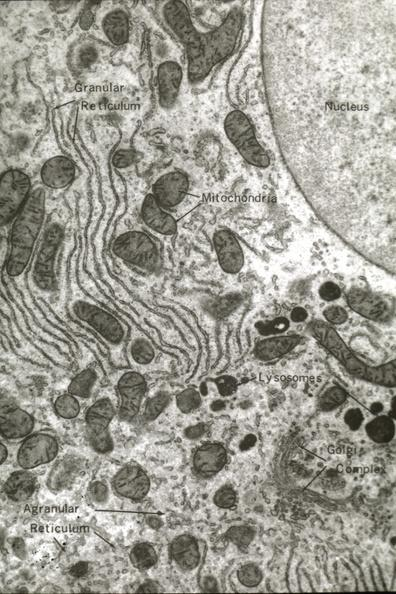what does this image show?
Answer the question using a single word or phrase. Structures labeled 